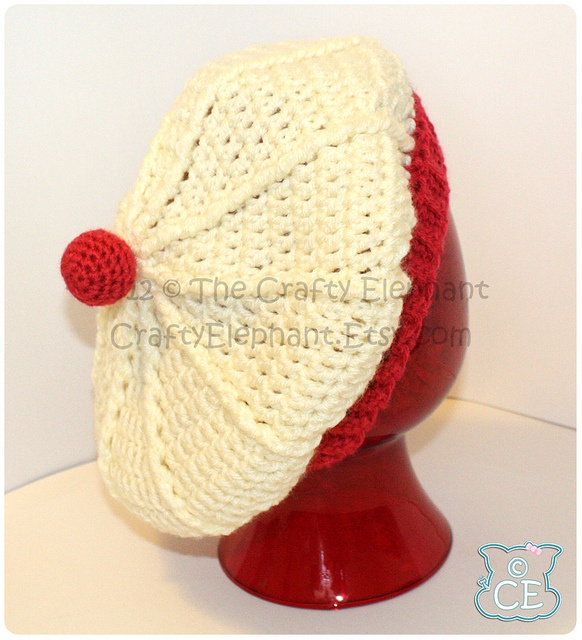Describe the objects in this image and their specific colors. I can see a vase in white, maroon, and brown tones in this image. 